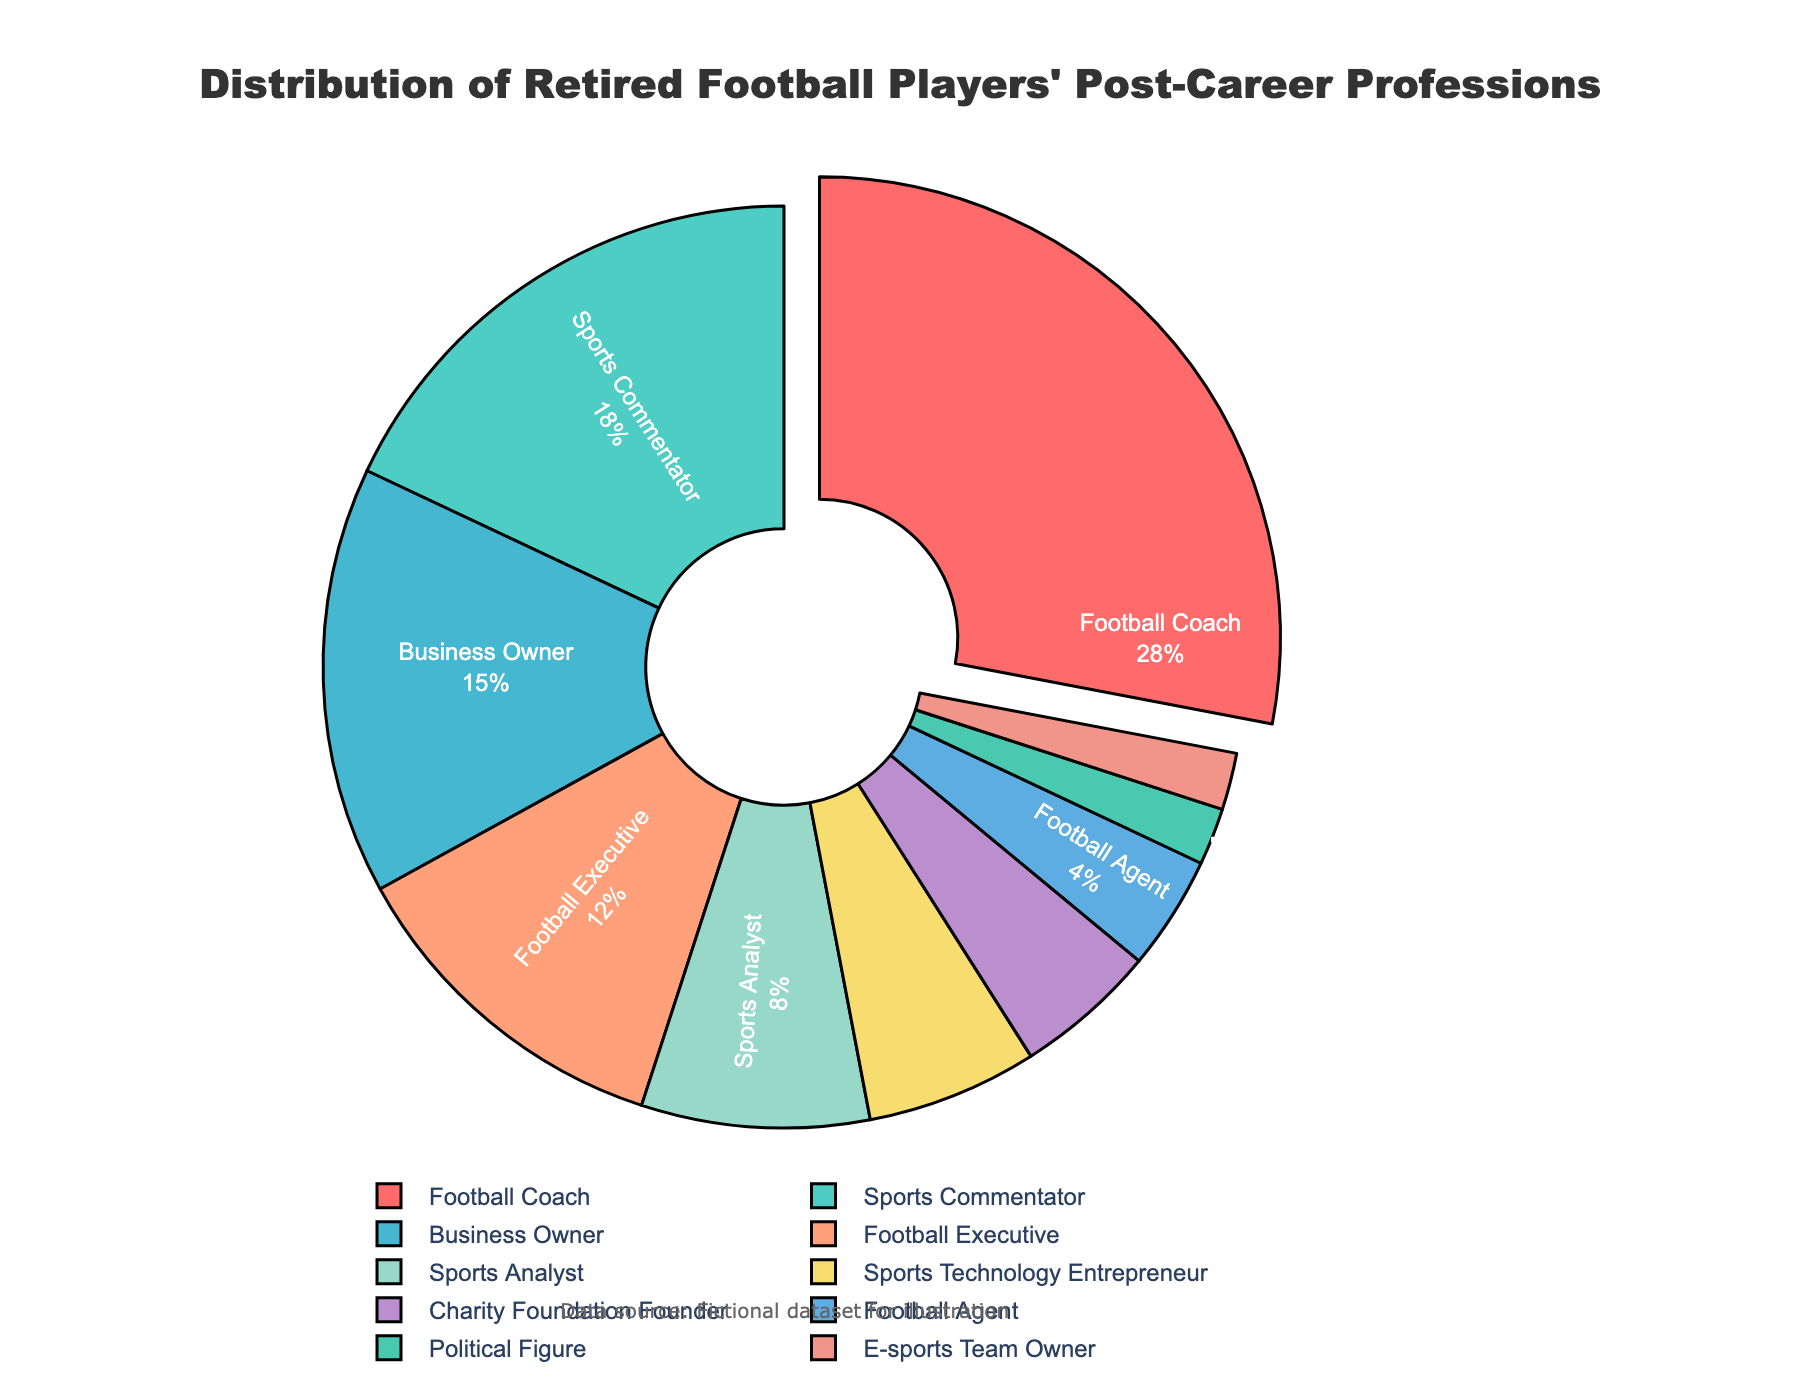What profession has the highest percentage of retired football players? Look at the profession section with the largest segment in the pie chart and check the percentage next to it.
Answer: Football Coach Which profession has a larger percentage, Business Owner or Sports Commentator? Compare the sizes of the segments labeled "Business Owner" and "Sports Commentator" in the pie chart. Sports Commentator has a larger segment than Business Owner.
Answer: Sports Commentator What is the sum of the percentages for Sports Analysts and Sports Technology Entrepreneurs? Add the percentages for Sports Analysts and Sports Technology Entrepreneurs: 8 + 6 = 14.
Answer: 14 How much more do Football Coaches represent compared to Football Executives? Subtract the percentage of Football Executives from the percentage of Football Coaches: 28 - 12 = 16.
Answer: 16 Are there any professions that retired football players choose equally based on percentage? Identify if any two segments in the pie chart have the same percentage value. E-sports Team Owner and Political Figure both have 2%.
Answer: Yes What is the combined percentage of retired football players in roles related to media (Sports Commentator and Sports Analyst)? Add the percentages for Sports Commentator and Sports Analyst: 18 + 8 = 26.
Answer: 26 Which professions have segments shown with a pull-out effect on the pie chart, and why? Identify segments with pull-out effect and describe that it's the profession with the highest percentage, which is Football Coach.
Answer: Football Coach Are there more retired players becoming Football Agents or Charity Foundation Founders? Compare the size of the segments labeled "Football Agent" and "Charity Foundation Founder". Charity Foundation Founder has a larger segment.
Answer: Charity Foundation Founder How does the percentage of retired players becoming Business Owners compare to those becoming Football Executives? Compare the percentages for Business Owners and Football Executives. Business Owners have a higher percentage than Football Executives.
Answer: Business Owners What is the percentage of retired football players involved in a profession with a less than 5% representation, and name them? Identify and sum up the percentages of professions with less than 5% representation: Football Agent, Political Figure, and E-sports Team Owner. 4 + 2 + 2 = 8.
Answer: 8, Football Agent, Political Figure, E-sports Team Owner 